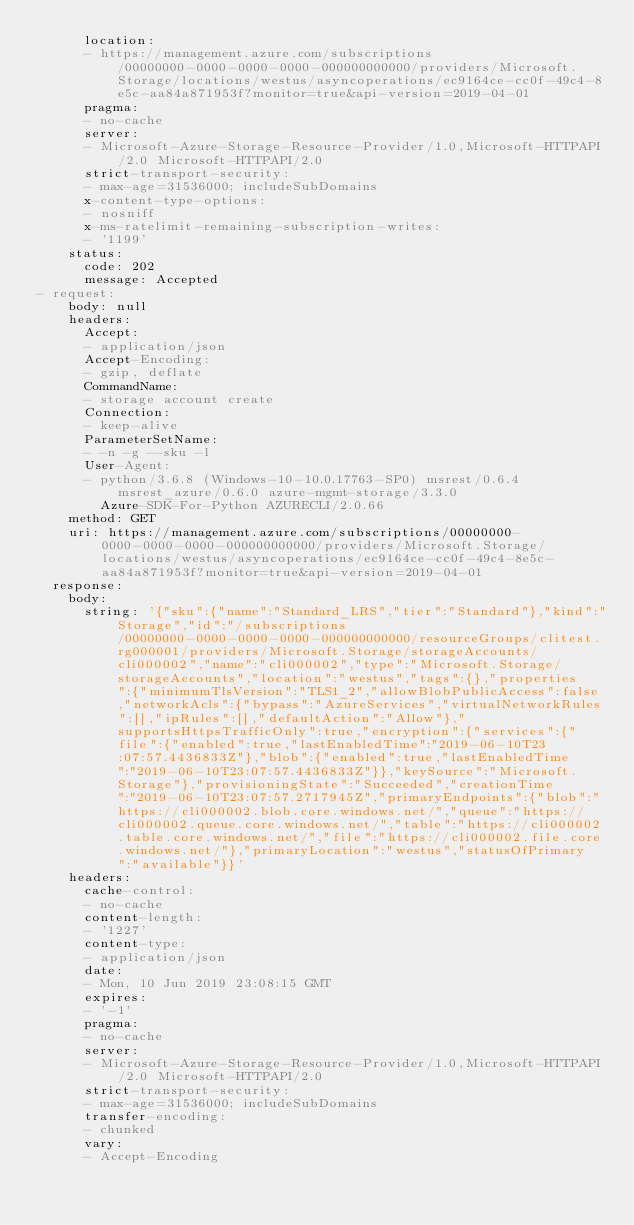<code> <loc_0><loc_0><loc_500><loc_500><_YAML_>      location:
      - https://management.azure.com/subscriptions/00000000-0000-0000-0000-000000000000/providers/Microsoft.Storage/locations/westus/asyncoperations/ec9164ce-cc0f-49c4-8e5c-aa84a871953f?monitor=true&api-version=2019-04-01
      pragma:
      - no-cache
      server:
      - Microsoft-Azure-Storage-Resource-Provider/1.0,Microsoft-HTTPAPI/2.0 Microsoft-HTTPAPI/2.0
      strict-transport-security:
      - max-age=31536000; includeSubDomains
      x-content-type-options:
      - nosniff
      x-ms-ratelimit-remaining-subscription-writes:
      - '1199'
    status:
      code: 202
      message: Accepted
- request:
    body: null
    headers:
      Accept:
      - application/json
      Accept-Encoding:
      - gzip, deflate
      CommandName:
      - storage account create
      Connection:
      - keep-alive
      ParameterSetName:
      - -n -g --sku -l
      User-Agent:
      - python/3.6.8 (Windows-10-10.0.17763-SP0) msrest/0.6.4 msrest_azure/0.6.0 azure-mgmt-storage/3.3.0
        Azure-SDK-For-Python AZURECLI/2.0.66
    method: GET
    uri: https://management.azure.com/subscriptions/00000000-0000-0000-0000-000000000000/providers/Microsoft.Storage/locations/westus/asyncoperations/ec9164ce-cc0f-49c4-8e5c-aa84a871953f?monitor=true&api-version=2019-04-01
  response:
    body:
      string: '{"sku":{"name":"Standard_LRS","tier":"Standard"},"kind":"Storage","id":"/subscriptions/00000000-0000-0000-0000-000000000000/resourceGroups/clitest.rg000001/providers/Microsoft.Storage/storageAccounts/cli000002","name":"cli000002","type":"Microsoft.Storage/storageAccounts","location":"westus","tags":{},"properties":{"minimumTlsVersion":"TLS1_2","allowBlobPublicAccess":false,"networkAcls":{"bypass":"AzureServices","virtualNetworkRules":[],"ipRules":[],"defaultAction":"Allow"},"supportsHttpsTrafficOnly":true,"encryption":{"services":{"file":{"enabled":true,"lastEnabledTime":"2019-06-10T23:07:57.4436833Z"},"blob":{"enabled":true,"lastEnabledTime":"2019-06-10T23:07:57.4436833Z"}},"keySource":"Microsoft.Storage"},"provisioningState":"Succeeded","creationTime":"2019-06-10T23:07:57.2717945Z","primaryEndpoints":{"blob":"https://cli000002.blob.core.windows.net/","queue":"https://cli000002.queue.core.windows.net/","table":"https://cli000002.table.core.windows.net/","file":"https://cli000002.file.core.windows.net/"},"primaryLocation":"westus","statusOfPrimary":"available"}}'
    headers:
      cache-control:
      - no-cache
      content-length:
      - '1227'
      content-type:
      - application/json
      date:
      - Mon, 10 Jun 2019 23:08:15 GMT
      expires:
      - '-1'
      pragma:
      - no-cache
      server:
      - Microsoft-Azure-Storage-Resource-Provider/1.0,Microsoft-HTTPAPI/2.0 Microsoft-HTTPAPI/2.0
      strict-transport-security:
      - max-age=31536000; includeSubDomains
      transfer-encoding:
      - chunked
      vary:
      - Accept-Encoding</code> 